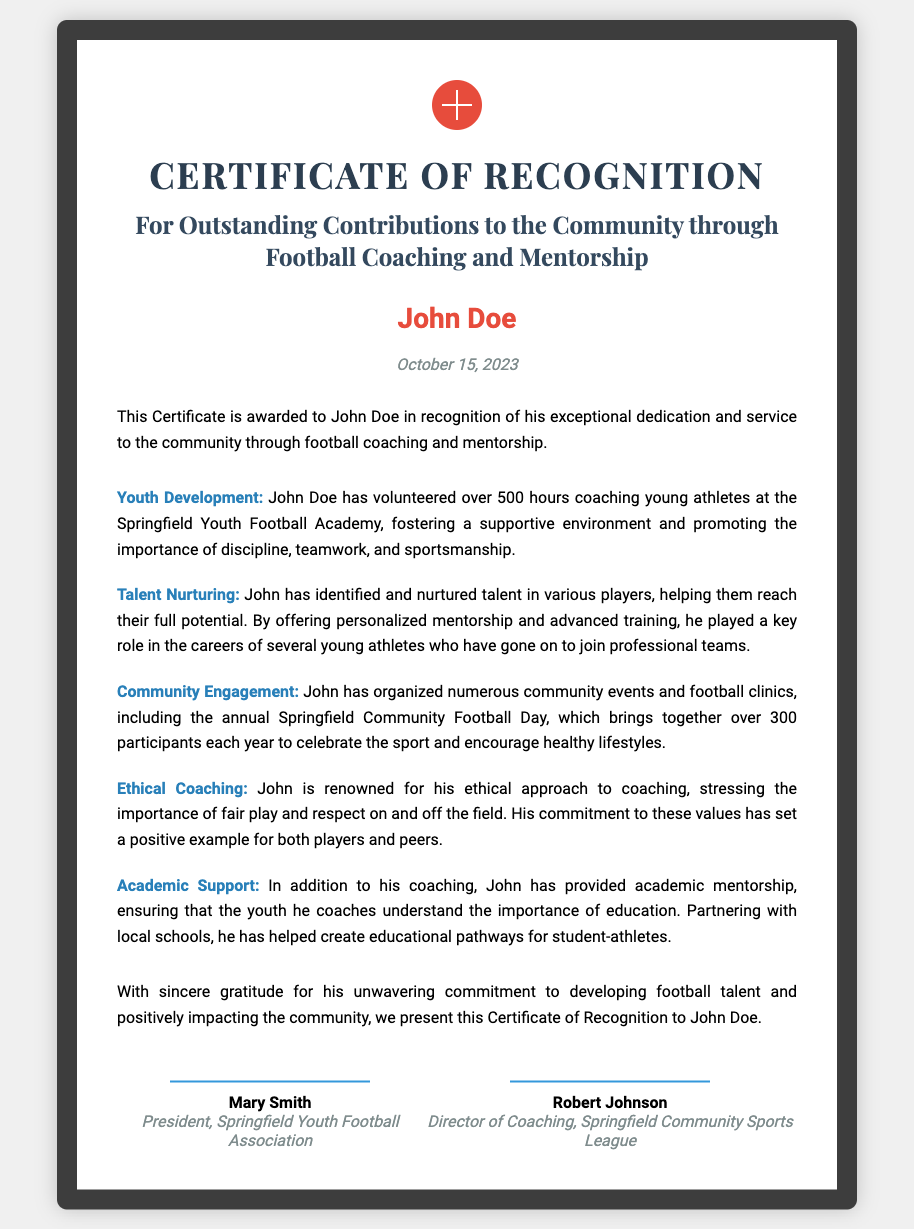What is the recipient's name? The recipient's name is prominently displayed in the document, indicating who is being recognized.
Answer: John Doe When was the certificate awarded? The date of the award is listed clearly in the document, showing when the recognition took place.
Answer: October 15, 2023 How many hours did John Doe volunteer? The document specifies the total hours John Doe volunteered, emphasizing his commitment to coaching.
Answer: 500 hours What organization does Mary Smith represent? The signature section includes names and positions, identifying who is endorsing the certificate.
Answer: Springfield Youth Football Association Which football academy did John Doe coach at? The document mentions the specific institution where John Doe has contributed significantly through coaching.
Answer: Springfield Youth Football Academy What is one of the ethical values John promotes? The document emphasizes the ethical coaching practices John instills in his athletes, reflecting his values.
Answer: Fair play What is one event organized by John Doe? The contributions section lists specific events that John has organized, highlighting his community engagement efforts.
Answer: Springfield Community Football Day Name one area where John provided academic support. The document mentions John’s efforts beyond sports, illustrating his holistic approach to mentorship.
Answer: Education 